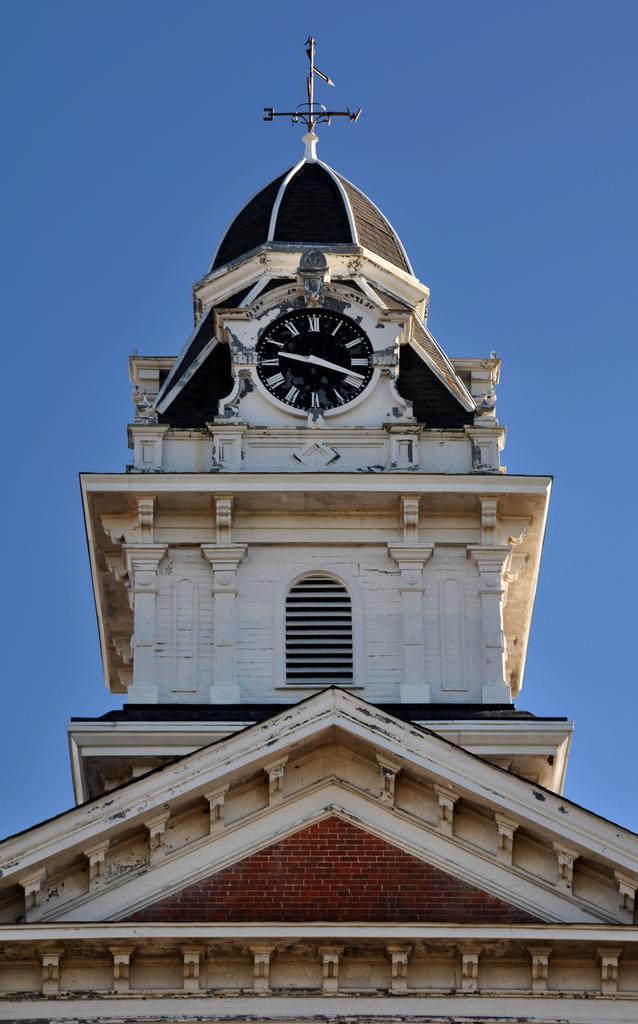Please provide a concise description of this image. In the foreground of the picture there is a building. In the center of the picture there is a clock. At the top there is a compass. In the background it is sky. 